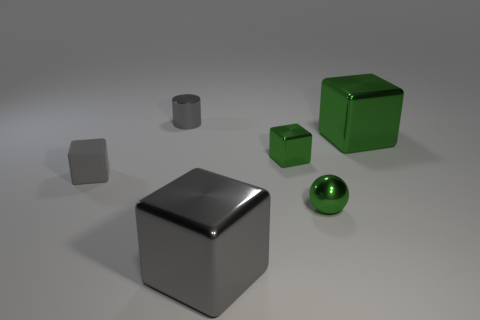There is another gray object that is the same shape as the small gray matte object; what is its material?
Your answer should be compact. Metal. There is a large block that is left of the large green block; what is its color?
Give a very brief answer. Gray. The metallic cylinder is what size?
Offer a terse response. Small. Do the shiny ball and the gray metal thing behind the small gray matte cube have the same size?
Provide a short and direct response. Yes. The large cube that is behind the block to the left of the big object in front of the small green metallic block is what color?
Ensure brevity in your answer.  Green. Is the large block to the right of the sphere made of the same material as the tiny cylinder?
Give a very brief answer. Yes. What number of other things are the same material as the green sphere?
Provide a short and direct response. 4. There is a gray thing that is the same size as the gray metal cylinder; what is it made of?
Make the answer very short. Rubber. There is a gray metallic object in front of the big green object; does it have the same shape as the big object that is behind the matte cube?
Offer a very short reply. Yes. What is the shape of the gray shiny object that is the same size as the green metal sphere?
Your answer should be compact. Cylinder. 